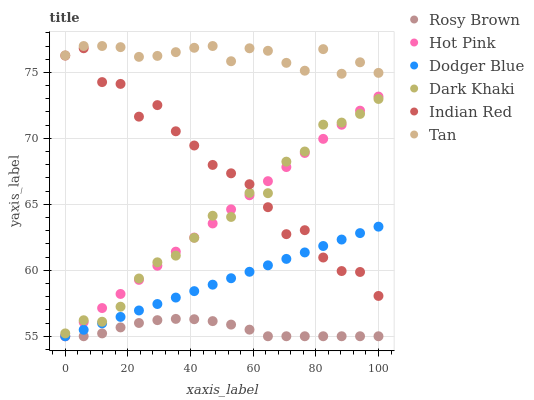Does Rosy Brown have the minimum area under the curve?
Answer yes or no. Yes. Does Tan have the maximum area under the curve?
Answer yes or no. Yes. Does Dark Khaki have the minimum area under the curve?
Answer yes or no. No. Does Dark Khaki have the maximum area under the curve?
Answer yes or no. No. Is Dodger Blue the smoothest?
Answer yes or no. Yes. Is Indian Red the roughest?
Answer yes or no. Yes. Is Rosy Brown the smoothest?
Answer yes or no. No. Is Rosy Brown the roughest?
Answer yes or no. No. Does Hot Pink have the lowest value?
Answer yes or no. Yes. Does Dark Khaki have the lowest value?
Answer yes or no. No. Does Tan have the highest value?
Answer yes or no. Yes. Does Dark Khaki have the highest value?
Answer yes or no. No. Is Rosy Brown less than Tan?
Answer yes or no. Yes. Is Tan greater than Dodger Blue?
Answer yes or no. Yes. Does Hot Pink intersect Dark Khaki?
Answer yes or no. Yes. Is Hot Pink less than Dark Khaki?
Answer yes or no. No. Is Hot Pink greater than Dark Khaki?
Answer yes or no. No. Does Rosy Brown intersect Tan?
Answer yes or no. No. 